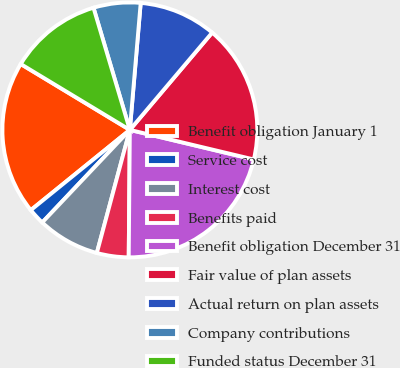Convert chart to OTSL. <chart><loc_0><loc_0><loc_500><loc_500><pie_chart><fcel>Benefit obligation January 1<fcel>Service cost<fcel>Interest cost<fcel>Benefits paid<fcel>Benefit obligation December 31<fcel>Fair value of plan assets<fcel>Actual return on plan assets<fcel>Company contributions<fcel>Funded status December 31<nl><fcel>19.48%<fcel>2.1%<fcel>7.89%<fcel>4.03%<fcel>21.41%<fcel>17.55%<fcel>9.82%<fcel>5.96%<fcel>11.75%<nl></chart> 